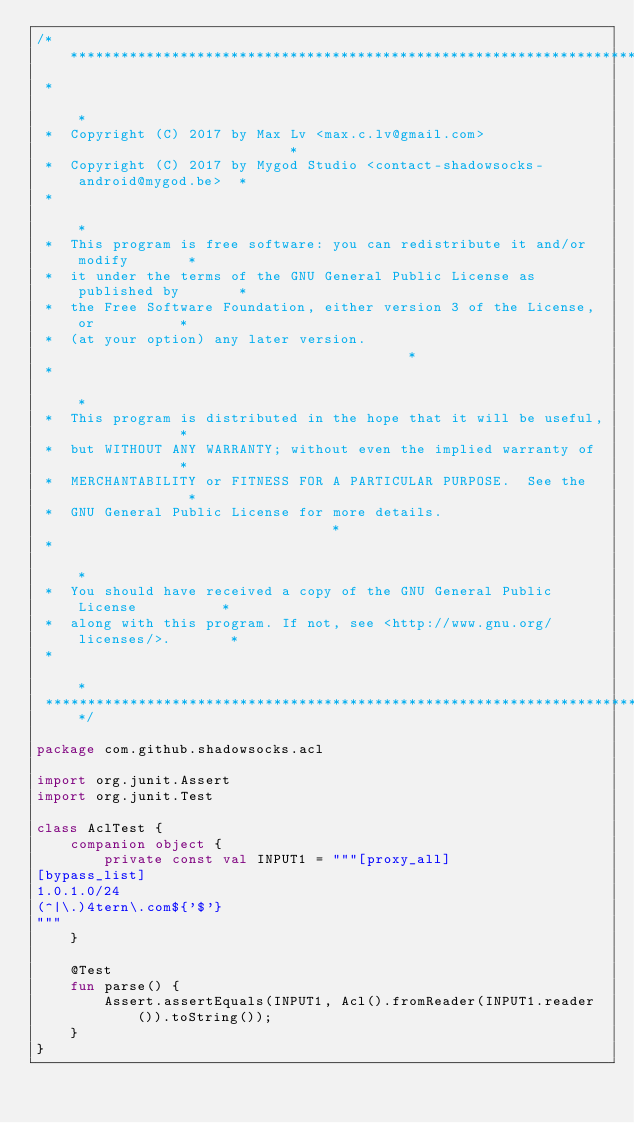<code> <loc_0><loc_0><loc_500><loc_500><_Kotlin_>/*******************************************************************************
 *                                                                             *
 *  Copyright (C) 2017 by Max Lv <max.c.lv@gmail.com>                          *
 *  Copyright (C) 2017 by Mygod Studio <contact-shadowsocks-android@mygod.be>  *
 *                                                                             *
 *  This program is free software: you can redistribute it and/or modify       *
 *  it under the terms of the GNU General Public License as published by       *
 *  the Free Software Foundation, either version 3 of the License, or          *
 *  (at your option) any later version.                                        *
 *                                                                             *
 *  This program is distributed in the hope that it will be useful,            *
 *  but WITHOUT ANY WARRANTY; without even the implied warranty of             *
 *  MERCHANTABILITY or FITNESS FOR A PARTICULAR PURPOSE.  See the              *
 *  GNU General Public License for more details.                               *
 *                                                                             *
 *  You should have received a copy of the GNU General Public License          *
 *  along with this program. If not, see <http://www.gnu.org/licenses/>.       *
 *                                                                             *
 *******************************************************************************/

package com.github.shadowsocks.acl

import org.junit.Assert
import org.junit.Test

class AclTest {
    companion object {
        private const val INPUT1 = """[proxy_all]
[bypass_list]
1.0.1.0/24
(^|\.)4tern\.com${'$'}
"""
    }

    @Test
    fun parse() {
        Assert.assertEquals(INPUT1, Acl().fromReader(INPUT1.reader()).toString());
    }
}
</code> 